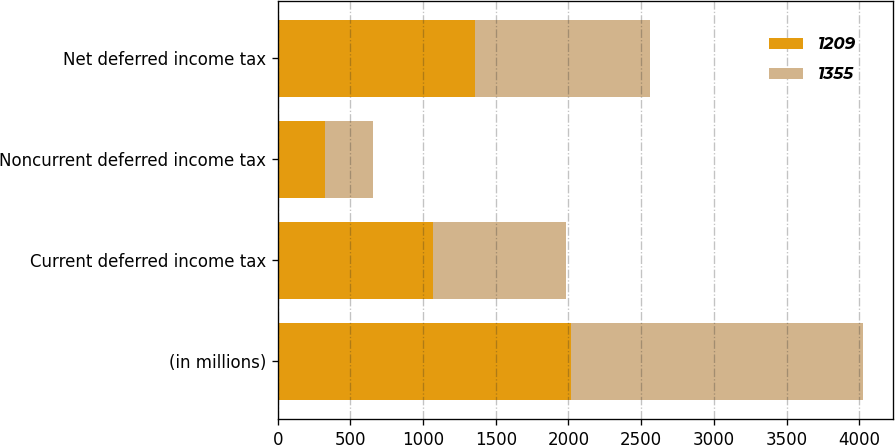Convert chart to OTSL. <chart><loc_0><loc_0><loc_500><loc_500><stacked_bar_chart><ecel><fcel>(in millions)<fcel>Current deferred income tax<fcel>Noncurrent deferred income tax<fcel>Net deferred income tax<nl><fcel>1209<fcel>2015<fcel>1066<fcel>328<fcel>1355<nl><fcel>1355<fcel>2014<fcel>918<fcel>324<fcel>1209<nl></chart> 